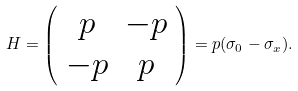Convert formula to latex. <formula><loc_0><loc_0><loc_500><loc_500>H = \left ( \begin{array} { c c } p & - p \\ - p & p \end{array} \right ) = p ( \sigma _ { 0 } - \sigma _ { x } ) .</formula> 